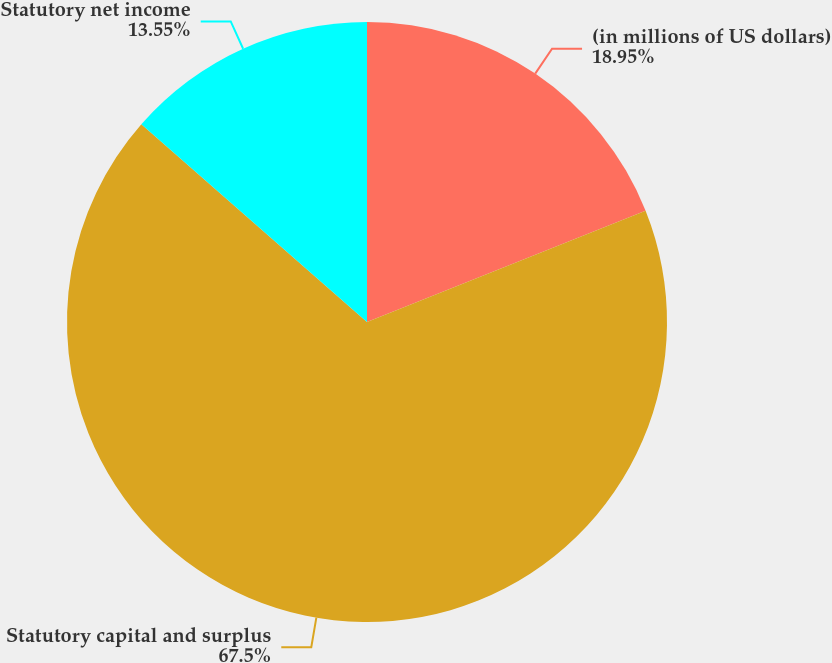Convert chart to OTSL. <chart><loc_0><loc_0><loc_500><loc_500><pie_chart><fcel>(in millions of US dollars)<fcel>Statutory capital and surplus<fcel>Statutory net income<nl><fcel>18.95%<fcel>67.5%<fcel>13.55%<nl></chart> 